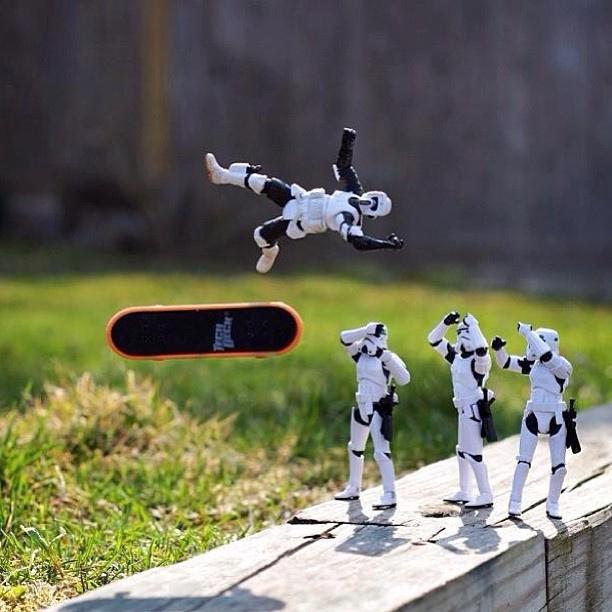What Star Wars characters are these?
Short answer required. Stormtroopers. Are these humans?
Be succinct. No. How many Star Wars figures are shown?
Answer briefly. 4. 